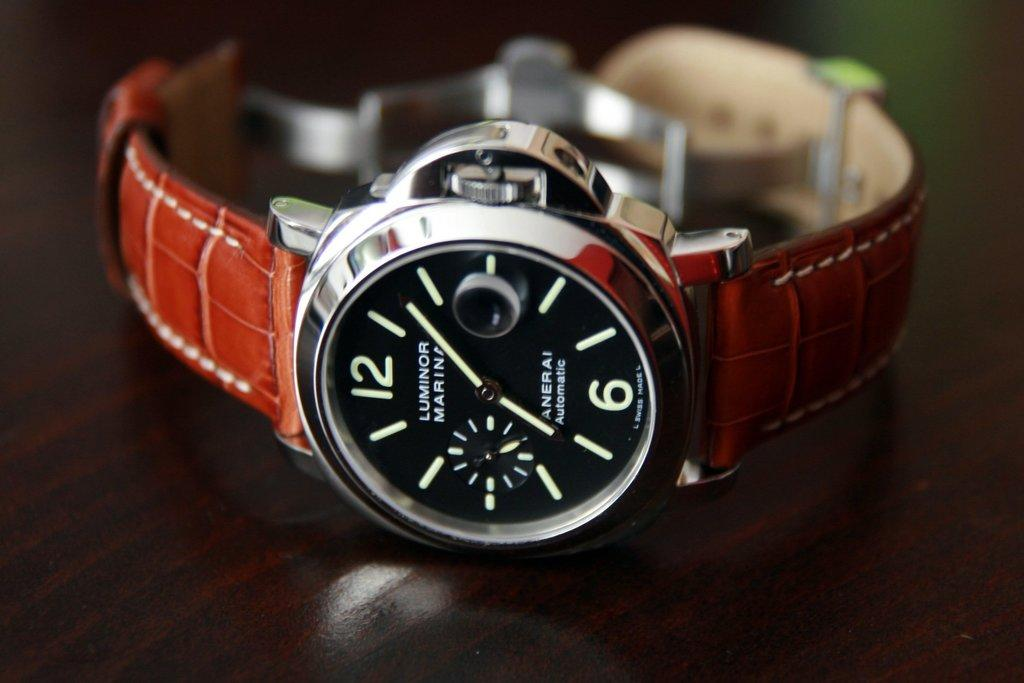What object is the main focus of the image? There is a watch in the image. What is the color of the surface on which the watch is placed? The watch is on a black surface. Can you describe the background of the image? The background of the image is blurred. What type of feather can be seen attached to the watch in the image? There is no feather present or attached to the watch in the image. 